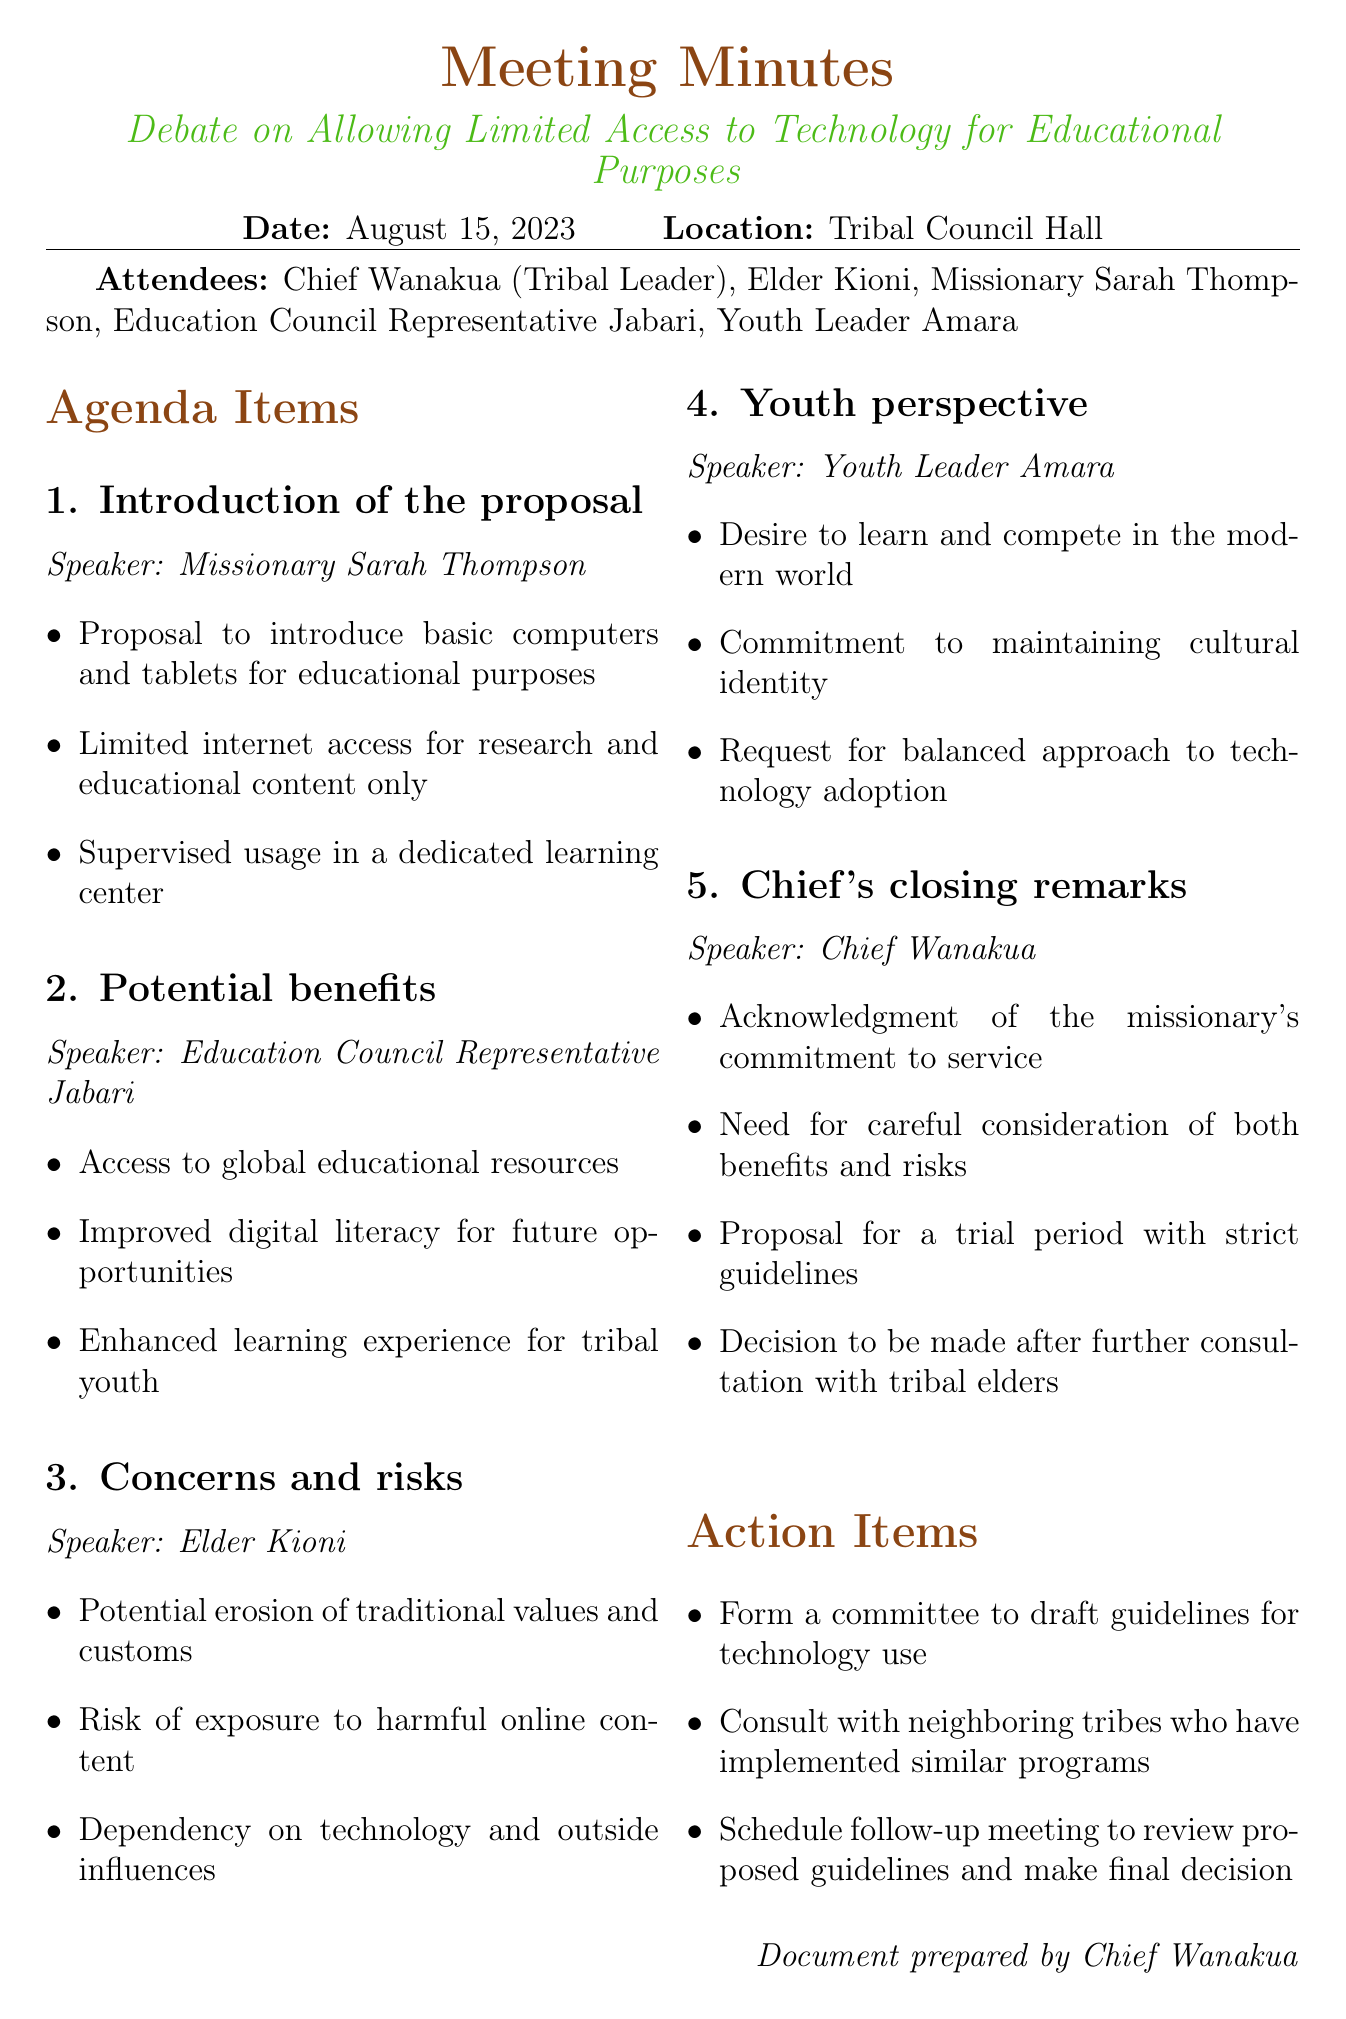what is the date of the meeting? The date of the meeting is explicitly stated in the document as August 15, 2023.
Answer: August 15, 2023 who introduced the proposal? The proposal is introduced by Missionary Sarah Thompson as indicated in the agenda item.
Answer: Missionary Sarah Thompson what is one potential benefit mentioned? One of the potential benefits discussed was improved digital literacy for future opportunities as stated in the document.
Answer: Improved digital literacy what concern was raised by Elder Kioni? Elder Kioni raised concerns about the potential erosion of traditional values and customs during the meeting.
Answer: Erosion of traditional values who represented the youth perspective? The youth perspective was represented by Youth Leader Amara.
Answer: Youth Leader Amara what action item involves consulting neighboring tribes? The action item regarding consulting neighboring tribes mentions that they should consult with those tribes who have implemented similar programs.
Answer: Consult with neighboring tribes what was proposed by Chief Wanakua concerning technology use? Chief Wanakua proposed a trial period with strict guidelines regarding the use of technology.
Answer: Trial period with strict guidelines how many attendees were present at the meeting? The document lists a total of five attendees present at the meeting.
Answer: Five attendees what was a request from the youth leader? The youth leader, Amara, requested a balanced approach to technology adoption.
Answer: Balanced approach to technology adoption 